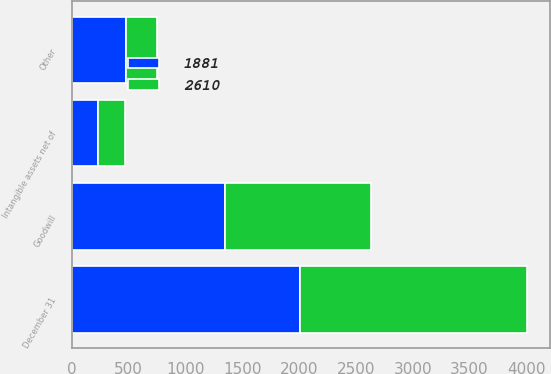<chart> <loc_0><loc_0><loc_500><loc_500><stacked_bar_chart><ecel><fcel>December 31<fcel>Goodwill<fcel>Intangible assets net of<fcel>Other<nl><fcel>1881<fcel>2005<fcel>1349<fcel>233<fcel>475<nl><fcel>2610<fcel>2004<fcel>1283<fcel>233<fcel>278<nl></chart> 